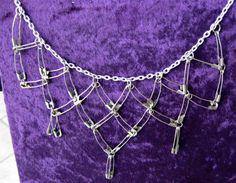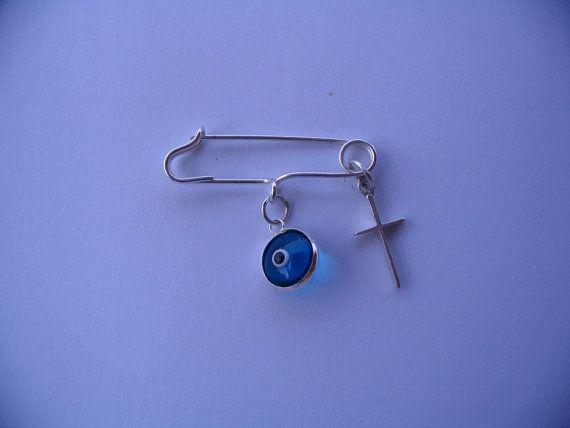The first image is the image on the left, the second image is the image on the right. Considering the images on both sides, is "An image shows a necklace designed to include at least one safety pin." valid? Answer yes or no. Yes. The first image is the image on the left, the second image is the image on the right. For the images displayed, is the sentence "The left image shows a single safety pin pinned on a blue cloth." factually correct? Answer yes or no. No. 